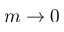Convert formula to latex. <formula><loc_0><loc_0><loc_500><loc_500>m \to 0</formula> 